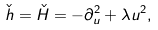<formula> <loc_0><loc_0><loc_500><loc_500>\check { h } = \check { H } = - \partial _ { u } ^ { 2 } + \lambda u ^ { 2 } ,</formula> 